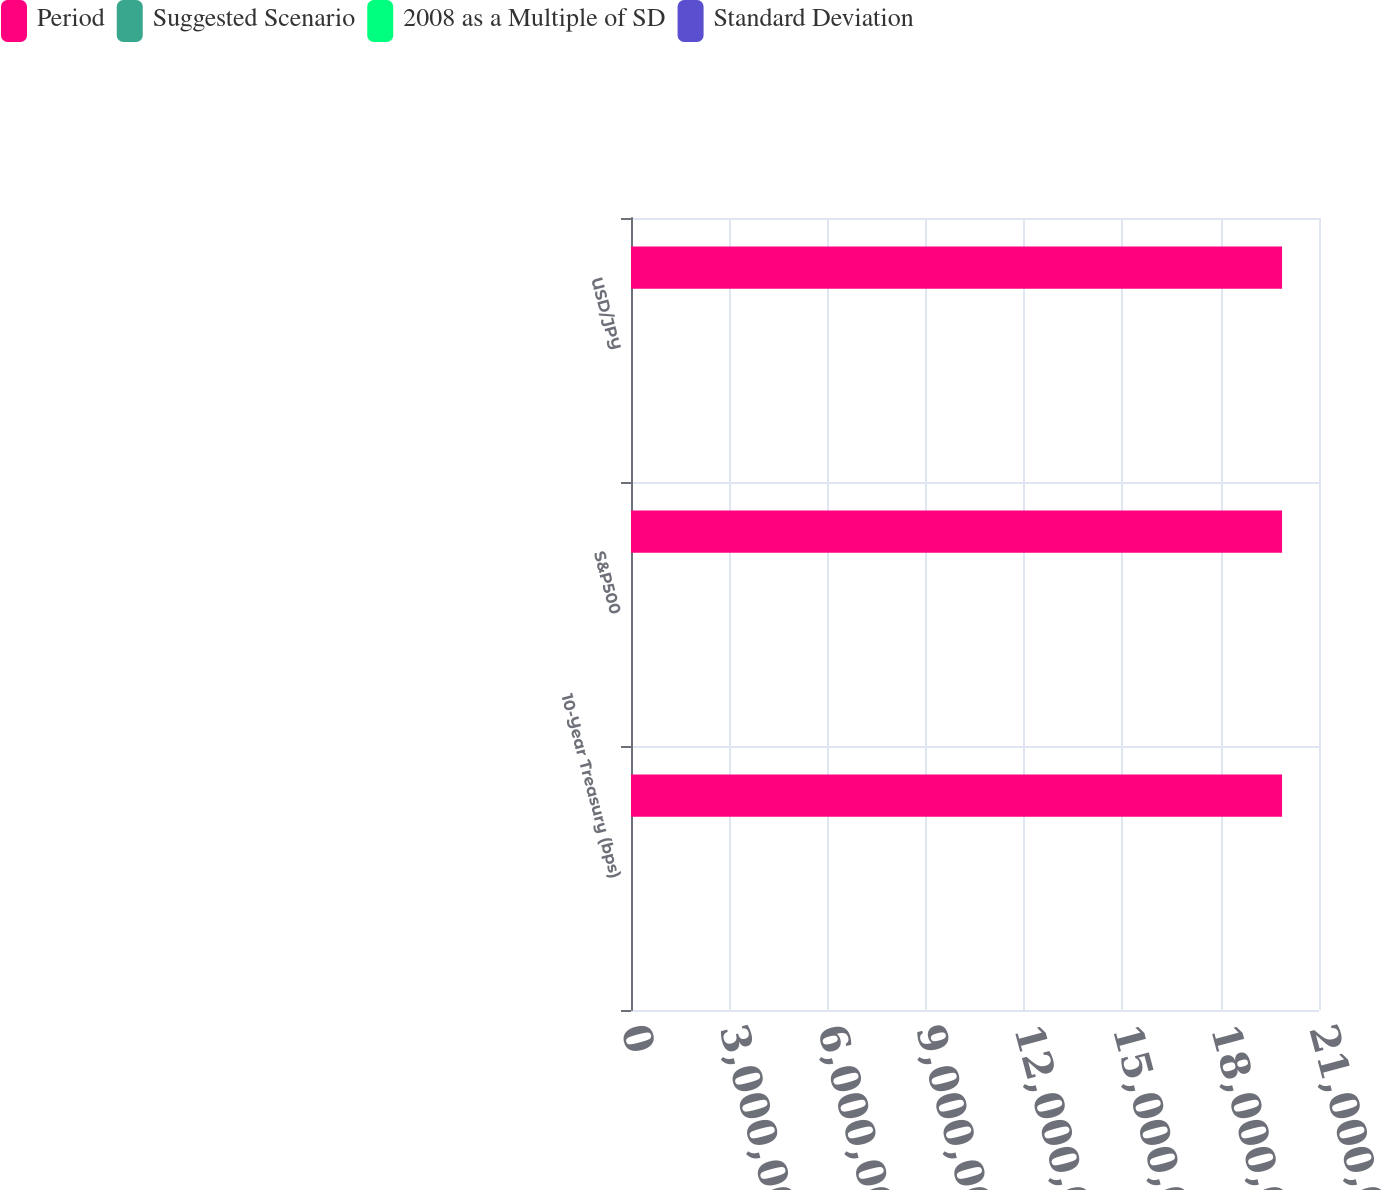Convert chart. <chart><loc_0><loc_0><loc_500><loc_500><stacked_bar_chart><ecel><fcel>10-Year Treasury (bps)<fcel>S&P500<fcel>USD/JPY<nl><fcel>Period<fcel>1.9872e+07<fcel>1.9872e+07<fcel>1.9872e+07<nl><fcel>Suggested Scenario<fcel>98.1<fcel>16.1<fcel>10<nl><fcel>2008 as a Multiple of SD<fcel>100<fcel>15<fcel>10<nl><fcel>Standard Deviation<fcel>1<fcel>0.9<fcel>1<nl></chart> 